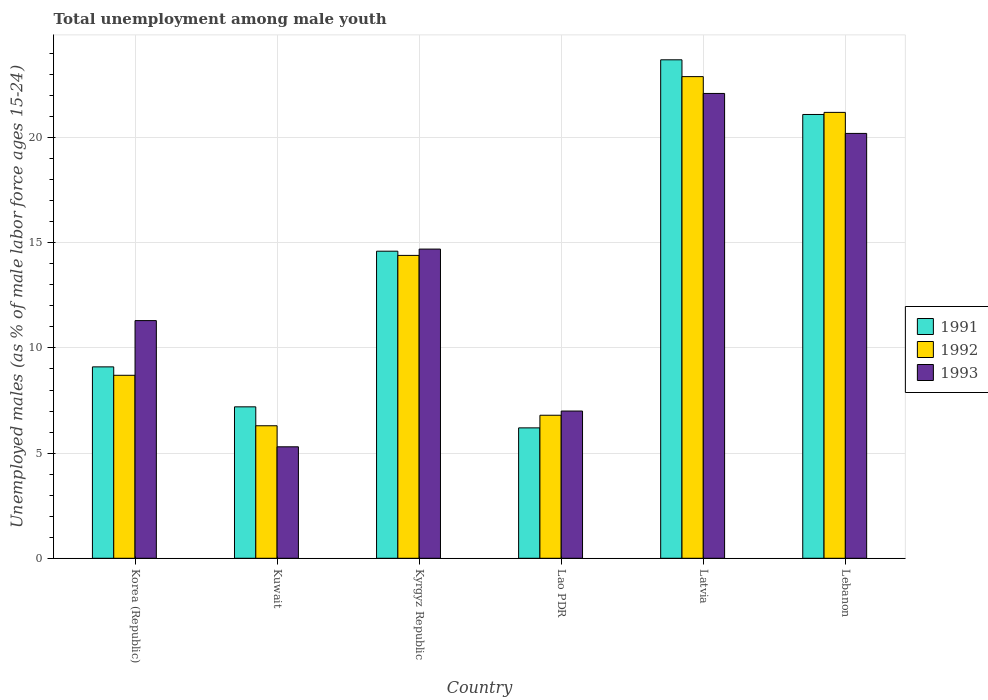How many groups of bars are there?
Your response must be concise. 6. Are the number of bars per tick equal to the number of legend labels?
Ensure brevity in your answer.  Yes. Are the number of bars on each tick of the X-axis equal?
Provide a succinct answer. Yes. What is the label of the 5th group of bars from the left?
Your answer should be very brief. Latvia. What is the percentage of unemployed males in in 1993 in Korea (Republic)?
Ensure brevity in your answer.  11.3. Across all countries, what is the maximum percentage of unemployed males in in 1993?
Offer a very short reply. 22.1. Across all countries, what is the minimum percentage of unemployed males in in 1992?
Your answer should be very brief. 6.3. In which country was the percentage of unemployed males in in 1993 maximum?
Ensure brevity in your answer.  Latvia. In which country was the percentage of unemployed males in in 1991 minimum?
Ensure brevity in your answer.  Lao PDR. What is the total percentage of unemployed males in in 1993 in the graph?
Your answer should be very brief. 80.6. What is the difference between the percentage of unemployed males in in 1992 in Lao PDR and that in Latvia?
Provide a succinct answer. -16.1. What is the difference between the percentage of unemployed males in in 1993 in Kyrgyz Republic and the percentage of unemployed males in in 1991 in Lebanon?
Ensure brevity in your answer.  -6.4. What is the average percentage of unemployed males in in 1991 per country?
Your answer should be compact. 13.65. What is the difference between the percentage of unemployed males in of/in 1991 and percentage of unemployed males in of/in 1992 in Lao PDR?
Ensure brevity in your answer.  -0.6. What is the ratio of the percentage of unemployed males in in 1993 in Kuwait to that in Lao PDR?
Ensure brevity in your answer.  0.76. Is the percentage of unemployed males in in 1993 in Kyrgyz Republic less than that in Lebanon?
Make the answer very short. Yes. What is the difference between the highest and the second highest percentage of unemployed males in in 1991?
Your answer should be very brief. 6.5. What is the difference between the highest and the lowest percentage of unemployed males in in 1991?
Your response must be concise. 17.5. In how many countries, is the percentage of unemployed males in in 1992 greater than the average percentage of unemployed males in in 1992 taken over all countries?
Offer a very short reply. 3. Is the sum of the percentage of unemployed males in in 1992 in Korea (Republic) and Kuwait greater than the maximum percentage of unemployed males in in 1991 across all countries?
Make the answer very short. No. What does the 2nd bar from the right in Lebanon represents?
Give a very brief answer. 1992. Is it the case that in every country, the sum of the percentage of unemployed males in in 1991 and percentage of unemployed males in in 1992 is greater than the percentage of unemployed males in in 1993?
Keep it short and to the point. Yes. How many bars are there?
Provide a short and direct response. 18. Are all the bars in the graph horizontal?
Offer a terse response. No. Does the graph contain any zero values?
Your answer should be compact. No. What is the title of the graph?
Make the answer very short. Total unemployment among male youth. Does "1980" appear as one of the legend labels in the graph?
Provide a succinct answer. No. What is the label or title of the Y-axis?
Your answer should be very brief. Unemployed males (as % of male labor force ages 15-24). What is the Unemployed males (as % of male labor force ages 15-24) in 1991 in Korea (Republic)?
Your answer should be very brief. 9.1. What is the Unemployed males (as % of male labor force ages 15-24) in 1992 in Korea (Republic)?
Provide a short and direct response. 8.7. What is the Unemployed males (as % of male labor force ages 15-24) in 1993 in Korea (Republic)?
Ensure brevity in your answer.  11.3. What is the Unemployed males (as % of male labor force ages 15-24) of 1991 in Kuwait?
Give a very brief answer. 7.2. What is the Unemployed males (as % of male labor force ages 15-24) in 1992 in Kuwait?
Provide a short and direct response. 6.3. What is the Unemployed males (as % of male labor force ages 15-24) in 1993 in Kuwait?
Make the answer very short. 5.3. What is the Unemployed males (as % of male labor force ages 15-24) of 1991 in Kyrgyz Republic?
Ensure brevity in your answer.  14.6. What is the Unemployed males (as % of male labor force ages 15-24) in 1992 in Kyrgyz Republic?
Your response must be concise. 14.4. What is the Unemployed males (as % of male labor force ages 15-24) of 1993 in Kyrgyz Republic?
Provide a succinct answer. 14.7. What is the Unemployed males (as % of male labor force ages 15-24) of 1991 in Lao PDR?
Your response must be concise. 6.2. What is the Unemployed males (as % of male labor force ages 15-24) in 1992 in Lao PDR?
Make the answer very short. 6.8. What is the Unemployed males (as % of male labor force ages 15-24) in 1991 in Latvia?
Make the answer very short. 23.7. What is the Unemployed males (as % of male labor force ages 15-24) in 1992 in Latvia?
Provide a succinct answer. 22.9. What is the Unemployed males (as % of male labor force ages 15-24) in 1993 in Latvia?
Make the answer very short. 22.1. What is the Unemployed males (as % of male labor force ages 15-24) in 1991 in Lebanon?
Provide a succinct answer. 21.1. What is the Unemployed males (as % of male labor force ages 15-24) of 1992 in Lebanon?
Provide a succinct answer. 21.2. What is the Unemployed males (as % of male labor force ages 15-24) in 1993 in Lebanon?
Ensure brevity in your answer.  20.2. Across all countries, what is the maximum Unemployed males (as % of male labor force ages 15-24) of 1991?
Ensure brevity in your answer.  23.7. Across all countries, what is the maximum Unemployed males (as % of male labor force ages 15-24) in 1992?
Offer a terse response. 22.9. Across all countries, what is the maximum Unemployed males (as % of male labor force ages 15-24) in 1993?
Offer a very short reply. 22.1. Across all countries, what is the minimum Unemployed males (as % of male labor force ages 15-24) of 1991?
Provide a succinct answer. 6.2. Across all countries, what is the minimum Unemployed males (as % of male labor force ages 15-24) of 1992?
Offer a very short reply. 6.3. Across all countries, what is the minimum Unemployed males (as % of male labor force ages 15-24) in 1993?
Offer a terse response. 5.3. What is the total Unemployed males (as % of male labor force ages 15-24) in 1991 in the graph?
Offer a very short reply. 81.9. What is the total Unemployed males (as % of male labor force ages 15-24) in 1992 in the graph?
Give a very brief answer. 80.3. What is the total Unemployed males (as % of male labor force ages 15-24) in 1993 in the graph?
Keep it short and to the point. 80.6. What is the difference between the Unemployed males (as % of male labor force ages 15-24) in 1992 in Korea (Republic) and that in Kuwait?
Ensure brevity in your answer.  2.4. What is the difference between the Unemployed males (as % of male labor force ages 15-24) in 1991 in Korea (Republic) and that in Kyrgyz Republic?
Offer a terse response. -5.5. What is the difference between the Unemployed males (as % of male labor force ages 15-24) of 1992 in Korea (Republic) and that in Lao PDR?
Give a very brief answer. 1.9. What is the difference between the Unemployed males (as % of male labor force ages 15-24) in 1991 in Korea (Republic) and that in Latvia?
Your answer should be compact. -14.6. What is the difference between the Unemployed males (as % of male labor force ages 15-24) of 1993 in Korea (Republic) and that in Latvia?
Provide a succinct answer. -10.8. What is the difference between the Unemployed males (as % of male labor force ages 15-24) in 1992 in Kuwait and that in Kyrgyz Republic?
Provide a succinct answer. -8.1. What is the difference between the Unemployed males (as % of male labor force ages 15-24) of 1993 in Kuwait and that in Kyrgyz Republic?
Provide a short and direct response. -9.4. What is the difference between the Unemployed males (as % of male labor force ages 15-24) of 1992 in Kuwait and that in Lao PDR?
Provide a short and direct response. -0.5. What is the difference between the Unemployed males (as % of male labor force ages 15-24) of 1991 in Kuwait and that in Latvia?
Your answer should be compact. -16.5. What is the difference between the Unemployed males (as % of male labor force ages 15-24) in 1992 in Kuwait and that in Latvia?
Give a very brief answer. -16.6. What is the difference between the Unemployed males (as % of male labor force ages 15-24) in 1993 in Kuwait and that in Latvia?
Your answer should be very brief. -16.8. What is the difference between the Unemployed males (as % of male labor force ages 15-24) of 1992 in Kuwait and that in Lebanon?
Offer a very short reply. -14.9. What is the difference between the Unemployed males (as % of male labor force ages 15-24) of 1993 in Kuwait and that in Lebanon?
Provide a succinct answer. -14.9. What is the difference between the Unemployed males (as % of male labor force ages 15-24) in 1991 in Kyrgyz Republic and that in Lao PDR?
Provide a succinct answer. 8.4. What is the difference between the Unemployed males (as % of male labor force ages 15-24) in 1993 in Kyrgyz Republic and that in Lao PDR?
Make the answer very short. 7.7. What is the difference between the Unemployed males (as % of male labor force ages 15-24) of 1991 in Kyrgyz Republic and that in Lebanon?
Your answer should be compact. -6.5. What is the difference between the Unemployed males (as % of male labor force ages 15-24) of 1992 in Kyrgyz Republic and that in Lebanon?
Keep it short and to the point. -6.8. What is the difference between the Unemployed males (as % of male labor force ages 15-24) in 1993 in Kyrgyz Republic and that in Lebanon?
Ensure brevity in your answer.  -5.5. What is the difference between the Unemployed males (as % of male labor force ages 15-24) in 1991 in Lao PDR and that in Latvia?
Ensure brevity in your answer.  -17.5. What is the difference between the Unemployed males (as % of male labor force ages 15-24) of 1992 in Lao PDR and that in Latvia?
Provide a short and direct response. -16.1. What is the difference between the Unemployed males (as % of male labor force ages 15-24) in 1993 in Lao PDR and that in Latvia?
Offer a very short reply. -15.1. What is the difference between the Unemployed males (as % of male labor force ages 15-24) of 1991 in Lao PDR and that in Lebanon?
Your answer should be compact. -14.9. What is the difference between the Unemployed males (as % of male labor force ages 15-24) in 1992 in Lao PDR and that in Lebanon?
Your response must be concise. -14.4. What is the difference between the Unemployed males (as % of male labor force ages 15-24) of 1993 in Lao PDR and that in Lebanon?
Offer a terse response. -13.2. What is the difference between the Unemployed males (as % of male labor force ages 15-24) of 1991 in Latvia and that in Lebanon?
Your answer should be compact. 2.6. What is the difference between the Unemployed males (as % of male labor force ages 15-24) of 1992 in Latvia and that in Lebanon?
Make the answer very short. 1.7. What is the difference between the Unemployed males (as % of male labor force ages 15-24) in 1993 in Latvia and that in Lebanon?
Your answer should be very brief. 1.9. What is the difference between the Unemployed males (as % of male labor force ages 15-24) in 1991 in Korea (Republic) and the Unemployed males (as % of male labor force ages 15-24) in 1992 in Kuwait?
Provide a succinct answer. 2.8. What is the difference between the Unemployed males (as % of male labor force ages 15-24) of 1991 in Korea (Republic) and the Unemployed males (as % of male labor force ages 15-24) of 1993 in Kuwait?
Provide a succinct answer. 3.8. What is the difference between the Unemployed males (as % of male labor force ages 15-24) in 1991 in Korea (Republic) and the Unemployed males (as % of male labor force ages 15-24) in 1993 in Kyrgyz Republic?
Provide a succinct answer. -5.6. What is the difference between the Unemployed males (as % of male labor force ages 15-24) of 1991 in Korea (Republic) and the Unemployed males (as % of male labor force ages 15-24) of 1993 in Lao PDR?
Offer a very short reply. 2.1. What is the difference between the Unemployed males (as % of male labor force ages 15-24) in 1992 in Korea (Republic) and the Unemployed males (as % of male labor force ages 15-24) in 1993 in Lao PDR?
Provide a succinct answer. 1.7. What is the difference between the Unemployed males (as % of male labor force ages 15-24) in 1991 in Korea (Republic) and the Unemployed males (as % of male labor force ages 15-24) in 1993 in Latvia?
Your response must be concise. -13. What is the difference between the Unemployed males (as % of male labor force ages 15-24) of 1992 in Korea (Republic) and the Unemployed males (as % of male labor force ages 15-24) of 1993 in Latvia?
Make the answer very short. -13.4. What is the difference between the Unemployed males (as % of male labor force ages 15-24) in 1991 in Korea (Republic) and the Unemployed males (as % of male labor force ages 15-24) in 1993 in Lebanon?
Offer a terse response. -11.1. What is the difference between the Unemployed males (as % of male labor force ages 15-24) in 1991 in Kuwait and the Unemployed males (as % of male labor force ages 15-24) in 1992 in Kyrgyz Republic?
Provide a succinct answer. -7.2. What is the difference between the Unemployed males (as % of male labor force ages 15-24) in 1992 in Kuwait and the Unemployed males (as % of male labor force ages 15-24) in 1993 in Kyrgyz Republic?
Your answer should be compact. -8.4. What is the difference between the Unemployed males (as % of male labor force ages 15-24) of 1992 in Kuwait and the Unemployed males (as % of male labor force ages 15-24) of 1993 in Lao PDR?
Offer a terse response. -0.7. What is the difference between the Unemployed males (as % of male labor force ages 15-24) of 1991 in Kuwait and the Unemployed males (as % of male labor force ages 15-24) of 1992 in Latvia?
Offer a terse response. -15.7. What is the difference between the Unemployed males (as % of male labor force ages 15-24) in 1991 in Kuwait and the Unemployed males (as % of male labor force ages 15-24) in 1993 in Latvia?
Provide a succinct answer. -14.9. What is the difference between the Unemployed males (as % of male labor force ages 15-24) of 1992 in Kuwait and the Unemployed males (as % of male labor force ages 15-24) of 1993 in Latvia?
Offer a very short reply. -15.8. What is the difference between the Unemployed males (as % of male labor force ages 15-24) of 1991 in Kuwait and the Unemployed males (as % of male labor force ages 15-24) of 1992 in Lebanon?
Make the answer very short. -14. What is the difference between the Unemployed males (as % of male labor force ages 15-24) in 1991 in Kyrgyz Republic and the Unemployed males (as % of male labor force ages 15-24) in 1993 in Lao PDR?
Provide a short and direct response. 7.6. What is the difference between the Unemployed males (as % of male labor force ages 15-24) in 1992 in Kyrgyz Republic and the Unemployed males (as % of male labor force ages 15-24) in 1993 in Lao PDR?
Offer a very short reply. 7.4. What is the difference between the Unemployed males (as % of male labor force ages 15-24) in 1991 in Kyrgyz Republic and the Unemployed males (as % of male labor force ages 15-24) in 1992 in Latvia?
Provide a short and direct response. -8.3. What is the difference between the Unemployed males (as % of male labor force ages 15-24) of 1992 in Kyrgyz Republic and the Unemployed males (as % of male labor force ages 15-24) of 1993 in Latvia?
Your answer should be compact. -7.7. What is the difference between the Unemployed males (as % of male labor force ages 15-24) in 1991 in Kyrgyz Republic and the Unemployed males (as % of male labor force ages 15-24) in 1992 in Lebanon?
Provide a succinct answer. -6.6. What is the difference between the Unemployed males (as % of male labor force ages 15-24) of 1992 in Kyrgyz Republic and the Unemployed males (as % of male labor force ages 15-24) of 1993 in Lebanon?
Keep it short and to the point. -5.8. What is the difference between the Unemployed males (as % of male labor force ages 15-24) in 1991 in Lao PDR and the Unemployed males (as % of male labor force ages 15-24) in 1992 in Latvia?
Keep it short and to the point. -16.7. What is the difference between the Unemployed males (as % of male labor force ages 15-24) in 1991 in Lao PDR and the Unemployed males (as % of male labor force ages 15-24) in 1993 in Latvia?
Give a very brief answer. -15.9. What is the difference between the Unemployed males (as % of male labor force ages 15-24) of 1992 in Lao PDR and the Unemployed males (as % of male labor force ages 15-24) of 1993 in Latvia?
Ensure brevity in your answer.  -15.3. What is the difference between the Unemployed males (as % of male labor force ages 15-24) in 1991 in Lao PDR and the Unemployed males (as % of male labor force ages 15-24) in 1993 in Lebanon?
Offer a terse response. -14. What is the average Unemployed males (as % of male labor force ages 15-24) in 1991 per country?
Provide a succinct answer. 13.65. What is the average Unemployed males (as % of male labor force ages 15-24) of 1992 per country?
Keep it short and to the point. 13.38. What is the average Unemployed males (as % of male labor force ages 15-24) of 1993 per country?
Ensure brevity in your answer.  13.43. What is the difference between the Unemployed males (as % of male labor force ages 15-24) in 1991 and Unemployed males (as % of male labor force ages 15-24) in 1992 in Korea (Republic)?
Provide a short and direct response. 0.4. What is the difference between the Unemployed males (as % of male labor force ages 15-24) in 1991 and Unemployed males (as % of male labor force ages 15-24) in 1992 in Kuwait?
Provide a short and direct response. 0.9. What is the difference between the Unemployed males (as % of male labor force ages 15-24) in 1992 and Unemployed males (as % of male labor force ages 15-24) in 1993 in Kuwait?
Provide a succinct answer. 1. What is the difference between the Unemployed males (as % of male labor force ages 15-24) in 1991 and Unemployed males (as % of male labor force ages 15-24) in 1992 in Lao PDR?
Your answer should be very brief. -0.6. What is the difference between the Unemployed males (as % of male labor force ages 15-24) of 1991 and Unemployed males (as % of male labor force ages 15-24) of 1992 in Latvia?
Provide a short and direct response. 0.8. What is the difference between the Unemployed males (as % of male labor force ages 15-24) in 1991 and Unemployed males (as % of male labor force ages 15-24) in 1993 in Latvia?
Ensure brevity in your answer.  1.6. What is the difference between the Unemployed males (as % of male labor force ages 15-24) in 1991 and Unemployed males (as % of male labor force ages 15-24) in 1992 in Lebanon?
Give a very brief answer. -0.1. What is the difference between the Unemployed males (as % of male labor force ages 15-24) of 1991 and Unemployed males (as % of male labor force ages 15-24) of 1993 in Lebanon?
Provide a succinct answer. 0.9. What is the difference between the Unemployed males (as % of male labor force ages 15-24) in 1992 and Unemployed males (as % of male labor force ages 15-24) in 1993 in Lebanon?
Keep it short and to the point. 1. What is the ratio of the Unemployed males (as % of male labor force ages 15-24) in 1991 in Korea (Republic) to that in Kuwait?
Your answer should be compact. 1.26. What is the ratio of the Unemployed males (as % of male labor force ages 15-24) of 1992 in Korea (Republic) to that in Kuwait?
Offer a terse response. 1.38. What is the ratio of the Unemployed males (as % of male labor force ages 15-24) of 1993 in Korea (Republic) to that in Kuwait?
Your answer should be compact. 2.13. What is the ratio of the Unemployed males (as % of male labor force ages 15-24) in 1991 in Korea (Republic) to that in Kyrgyz Republic?
Keep it short and to the point. 0.62. What is the ratio of the Unemployed males (as % of male labor force ages 15-24) in 1992 in Korea (Republic) to that in Kyrgyz Republic?
Offer a very short reply. 0.6. What is the ratio of the Unemployed males (as % of male labor force ages 15-24) of 1993 in Korea (Republic) to that in Kyrgyz Republic?
Make the answer very short. 0.77. What is the ratio of the Unemployed males (as % of male labor force ages 15-24) of 1991 in Korea (Republic) to that in Lao PDR?
Give a very brief answer. 1.47. What is the ratio of the Unemployed males (as % of male labor force ages 15-24) of 1992 in Korea (Republic) to that in Lao PDR?
Offer a very short reply. 1.28. What is the ratio of the Unemployed males (as % of male labor force ages 15-24) in 1993 in Korea (Republic) to that in Lao PDR?
Provide a succinct answer. 1.61. What is the ratio of the Unemployed males (as % of male labor force ages 15-24) of 1991 in Korea (Republic) to that in Latvia?
Offer a terse response. 0.38. What is the ratio of the Unemployed males (as % of male labor force ages 15-24) in 1992 in Korea (Republic) to that in Latvia?
Your answer should be compact. 0.38. What is the ratio of the Unemployed males (as % of male labor force ages 15-24) in 1993 in Korea (Republic) to that in Latvia?
Give a very brief answer. 0.51. What is the ratio of the Unemployed males (as % of male labor force ages 15-24) of 1991 in Korea (Republic) to that in Lebanon?
Offer a terse response. 0.43. What is the ratio of the Unemployed males (as % of male labor force ages 15-24) in 1992 in Korea (Republic) to that in Lebanon?
Your response must be concise. 0.41. What is the ratio of the Unemployed males (as % of male labor force ages 15-24) in 1993 in Korea (Republic) to that in Lebanon?
Provide a succinct answer. 0.56. What is the ratio of the Unemployed males (as % of male labor force ages 15-24) of 1991 in Kuwait to that in Kyrgyz Republic?
Give a very brief answer. 0.49. What is the ratio of the Unemployed males (as % of male labor force ages 15-24) of 1992 in Kuwait to that in Kyrgyz Republic?
Provide a succinct answer. 0.44. What is the ratio of the Unemployed males (as % of male labor force ages 15-24) of 1993 in Kuwait to that in Kyrgyz Republic?
Offer a very short reply. 0.36. What is the ratio of the Unemployed males (as % of male labor force ages 15-24) in 1991 in Kuwait to that in Lao PDR?
Offer a very short reply. 1.16. What is the ratio of the Unemployed males (as % of male labor force ages 15-24) in 1992 in Kuwait to that in Lao PDR?
Your response must be concise. 0.93. What is the ratio of the Unemployed males (as % of male labor force ages 15-24) of 1993 in Kuwait to that in Lao PDR?
Give a very brief answer. 0.76. What is the ratio of the Unemployed males (as % of male labor force ages 15-24) in 1991 in Kuwait to that in Latvia?
Your response must be concise. 0.3. What is the ratio of the Unemployed males (as % of male labor force ages 15-24) of 1992 in Kuwait to that in Latvia?
Ensure brevity in your answer.  0.28. What is the ratio of the Unemployed males (as % of male labor force ages 15-24) in 1993 in Kuwait to that in Latvia?
Offer a terse response. 0.24. What is the ratio of the Unemployed males (as % of male labor force ages 15-24) in 1991 in Kuwait to that in Lebanon?
Make the answer very short. 0.34. What is the ratio of the Unemployed males (as % of male labor force ages 15-24) of 1992 in Kuwait to that in Lebanon?
Your response must be concise. 0.3. What is the ratio of the Unemployed males (as % of male labor force ages 15-24) of 1993 in Kuwait to that in Lebanon?
Give a very brief answer. 0.26. What is the ratio of the Unemployed males (as % of male labor force ages 15-24) of 1991 in Kyrgyz Republic to that in Lao PDR?
Your answer should be very brief. 2.35. What is the ratio of the Unemployed males (as % of male labor force ages 15-24) of 1992 in Kyrgyz Republic to that in Lao PDR?
Offer a terse response. 2.12. What is the ratio of the Unemployed males (as % of male labor force ages 15-24) of 1991 in Kyrgyz Republic to that in Latvia?
Your answer should be very brief. 0.62. What is the ratio of the Unemployed males (as % of male labor force ages 15-24) of 1992 in Kyrgyz Republic to that in Latvia?
Your answer should be very brief. 0.63. What is the ratio of the Unemployed males (as % of male labor force ages 15-24) in 1993 in Kyrgyz Republic to that in Latvia?
Offer a terse response. 0.67. What is the ratio of the Unemployed males (as % of male labor force ages 15-24) in 1991 in Kyrgyz Republic to that in Lebanon?
Your response must be concise. 0.69. What is the ratio of the Unemployed males (as % of male labor force ages 15-24) in 1992 in Kyrgyz Republic to that in Lebanon?
Give a very brief answer. 0.68. What is the ratio of the Unemployed males (as % of male labor force ages 15-24) of 1993 in Kyrgyz Republic to that in Lebanon?
Offer a terse response. 0.73. What is the ratio of the Unemployed males (as % of male labor force ages 15-24) of 1991 in Lao PDR to that in Latvia?
Your answer should be compact. 0.26. What is the ratio of the Unemployed males (as % of male labor force ages 15-24) of 1992 in Lao PDR to that in Latvia?
Your response must be concise. 0.3. What is the ratio of the Unemployed males (as % of male labor force ages 15-24) of 1993 in Lao PDR to that in Latvia?
Your answer should be compact. 0.32. What is the ratio of the Unemployed males (as % of male labor force ages 15-24) of 1991 in Lao PDR to that in Lebanon?
Give a very brief answer. 0.29. What is the ratio of the Unemployed males (as % of male labor force ages 15-24) in 1992 in Lao PDR to that in Lebanon?
Your response must be concise. 0.32. What is the ratio of the Unemployed males (as % of male labor force ages 15-24) of 1993 in Lao PDR to that in Lebanon?
Offer a very short reply. 0.35. What is the ratio of the Unemployed males (as % of male labor force ages 15-24) in 1991 in Latvia to that in Lebanon?
Give a very brief answer. 1.12. What is the ratio of the Unemployed males (as % of male labor force ages 15-24) of 1992 in Latvia to that in Lebanon?
Offer a very short reply. 1.08. What is the ratio of the Unemployed males (as % of male labor force ages 15-24) of 1993 in Latvia to that in Lebanon?
Offer a very short reply. 1.09. What is the difference between the highest and the second highest Unemployed males (as % of male labor force ages 15-24) in 1991?
Provide a short and direct response. 2.6. What is the difference between the highest and the second highest Unemployed males (as % of male labor force ages 15-24) in 1992?
Your answer should be very brief. 1.7. What is the difference between the highest and the second highest Unemployed males (as % of male labor force ages 15-24) of 1993?
Provide a succinct answer. 1.9. What is the difference between the highest and the lowest Unemployed males (as % of male labor force ages 15-24) in 1993?
Offer a very short reply. 16.8. 